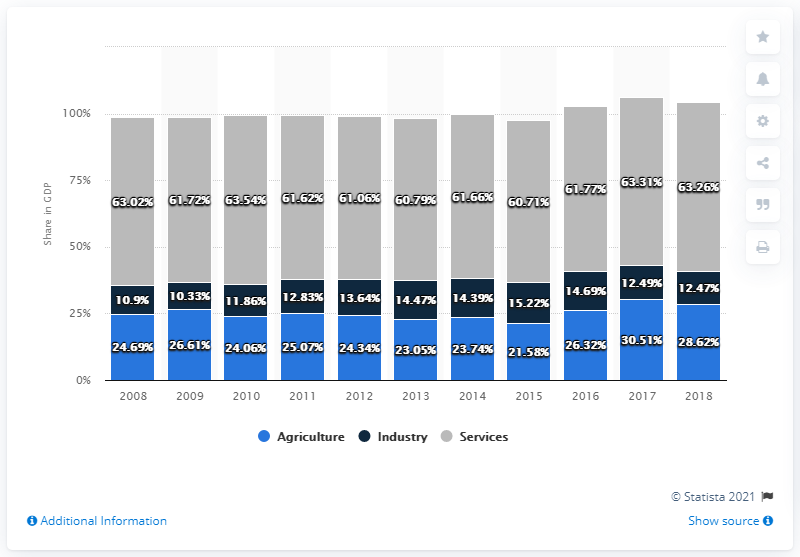Point out several critical features in this image. The total number of services provided from 2016 through 2018 is 188.34. The light blue segment on the graph represents agriculture, which is a sector that has been negatively impacted by the COVID-19 pandemic. 